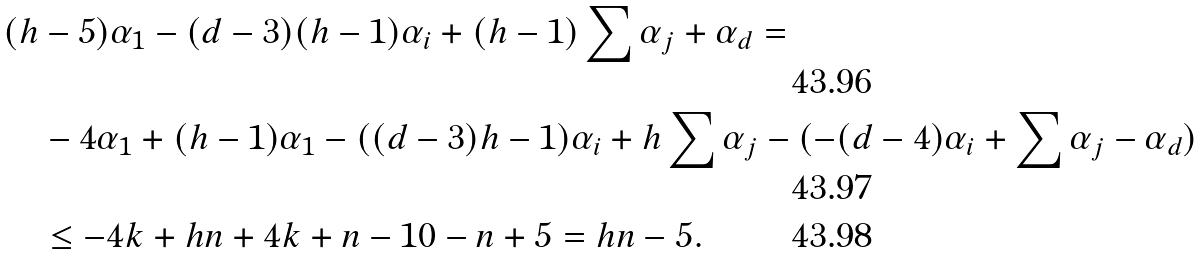Convert formula to latex. <formula><loc_0><loc_0><loc_500><loc_500>& ( h - 5 ) \alpha _ { 1 } - ( d - 3 ) ( h - 1 ) \alpha _ { i } + ( h - 1 ) \sum \alpha _ { j } + \alpha _ { d } = \\ & \quad - 4 \alpha _ { 1 } + ( h - 1 ) \alpha _ { 1 } - ( ( d - 3 ) h - 1 ) \alpha _ { i } + h \sum \alpha _ { j } - ( - ( d - 4 ) \alpha _ { i } + \sum \alpha _ { j } - \alpha _ { d } ) \\ & \quad \leq - 4 k + h n + 4 k + n - 1 0 - n + 5 = h n - 5 .</formula> 